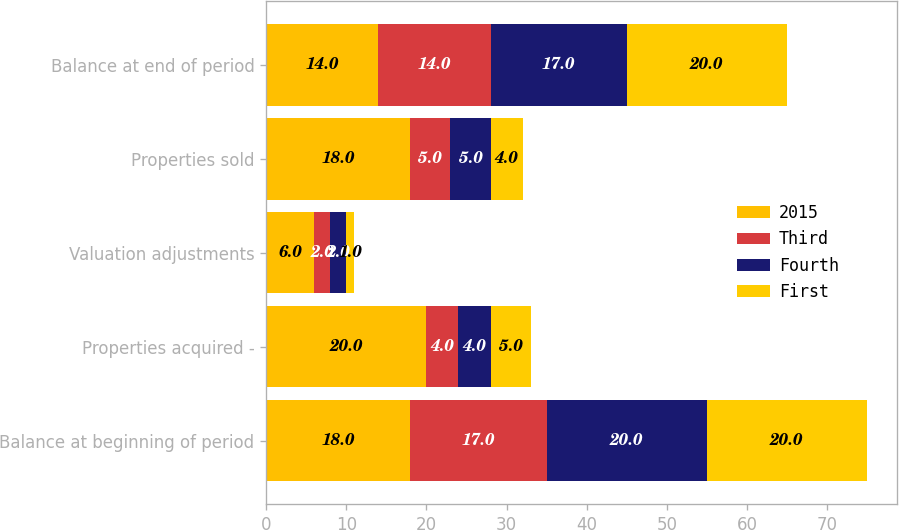<chart> <loc_0><loc_0><loc_500><loc_500><stacked_bar_chart><ecel><fcel>Balance at beginning of period<fcel>Properties acquired -<fcel>Valuation adjustments<fcel>Properties sold<fcel>Balance at end of period<nl><fcel>2015<fcel>18<fcel>20<fcel>6<fcel>18<fcel>14<nl><fcel>Third<fcel>17<fcel>4<fcel>2<fcel>5<fcel>14<nl><fcel>Fourth<fcel>20<fcel>4<fcel>2<fcel>5<fcel>17<nl><fcel>First<fcel>20<fcel>5<fcel>1<fcel>4<fcel>20<nl></chart> 